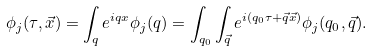<formula> <loc_0><loc_0><loc_500><loc_500>\phi _ { j } ( \tau , \vec { x } ) = \int _ { q } e ^ { i q x } \phi _ { j } ( q ) = \int _ { q _ { 0 } } \int _ { \vec { q } } e ^ { i ( q _ { 0 } \tau + \vec { q } \vec { x } ) } \phi _ { j } ( q _ { 0 } , \vec { q } ) .</formula> 